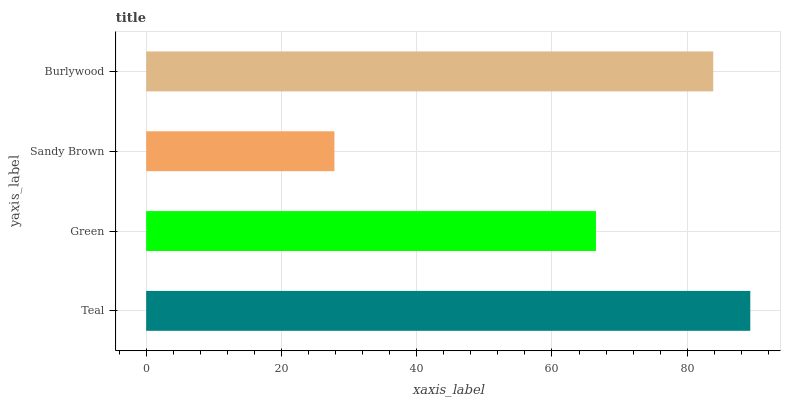Is Sandy Brown the minimum?
Answer yes or no. Yes. Is Teal the maximum?
Answer yes or no. Yes. Is Green the minimum?
Answer yes or no. No. Is Green the maximum?
Answer yes or no. No. Is Teal greater than Green?
Answer yes or no. Yes. Is Green less than Teal?
Answer yes or no. Yes. Is Green greater than Teal?
Answer yes or no. No. Is Teal less than Green?
Answer yes or no. No. Is Burlywood the high median?
Answer yes or no. Yes. Is Green the low median?
Answer yes or no. Yes. Is Teal the high median?
Answer yes or no. No. Is Burlywood the low median?
Answer yes or no. No. 